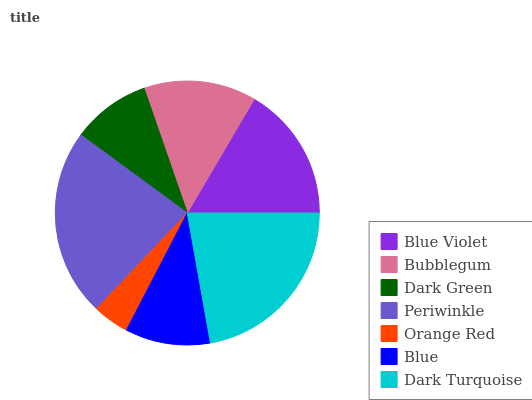Is Orange Red the minimum?
Answer yes or no. Yes. Is Periwinkle the maximum?
Answer yes or no. Yes. Is Bubblegum the minimum?
Answer yes or no. No. Is Bubblegum the maximum?
Answer yes or no. No. Is Blue Violet greater than Bubblegum?
Answer yes or no. Yes. Is Bubblegum less than Blue Violet?
Answer yes or no. Yes. Is Bubblegum greater than Blue Violet?
Answer yes or no. No. Is Blue Violet less than Bubblegum?
Answer yes or no. No. Is Bubblegum the high median?
Answer yes or no. Yes. Is Bubblegum the low median?
Answer yes or no. Yes. Is Blue Violet the high median?
Answer yes or no. No. Is Blue Violet the low median?
Answer yes or no. No. 